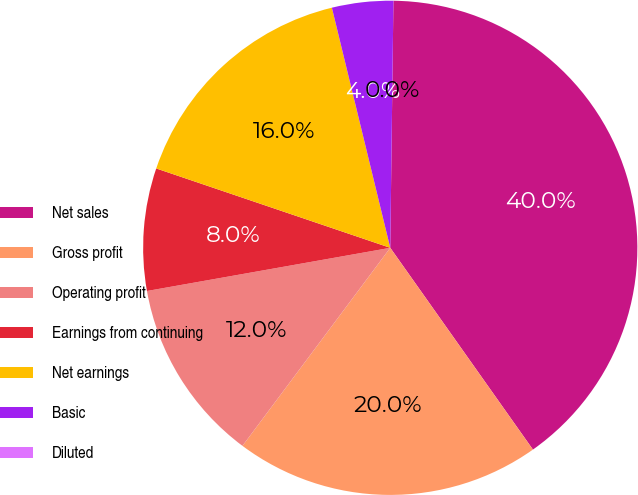Convert chart. <chart><loc_0><loc_0><loc_500><loc_500><pie_chart><fcel>Net sales<fcel>Gross profit<fcel>Operating profit<fcel>Earnings from continuing<fcel>Net earnings<fcel>Basic<fcel>Diluted<nl><fcel>40.0%<fcel>20.0%<fcel>12.0%<fcel>8.0%<fcel>16.0%<fcel>4.0%<fcel>0.0%<nl></chart> 